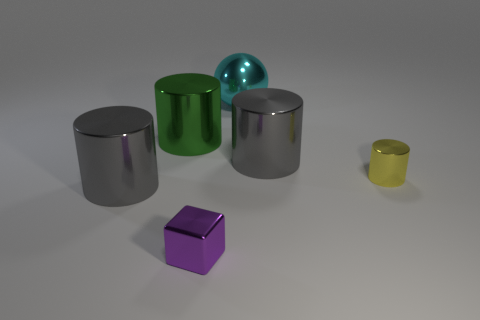Are there any other things that are the same shape as the cyan metal thing?
Your answer should be very brief. No. How many objects are tiny objects on the right side of the purple metallic object or tiny purple metallic things?
Provide a short and direct response. 2. Is the color of the large thing that is right of the large cyan metal thing the same as the block?
Your response must be concise. No. There is a gray thing in front of the small yellow object in front of the green metal cylinder; what shape is it?
Provide a short and direct response. Cylinder. Is the number of tiny things that are to the left of the green object less than the number of cyan shiny balls on the left side of the tiny purple object?
Your response must be concise. No. There is a green thing that is the same shape as the yellow object; what is its size?
Make the answer very short. Large. Are there any other things that are the same size as the purple block?
Your answer should be very brief. Yes. What number of things are large gray cylinders behind the tiny cube or tiny things behind the purple thing?
Ensure brevity in your answer.  3. Is the size of the yellow cylinder the same as the purple block?
Offer a terse response. Yes. Are there more shiny balls than large green metal balls?
Your answer should be very brief. Yes. 